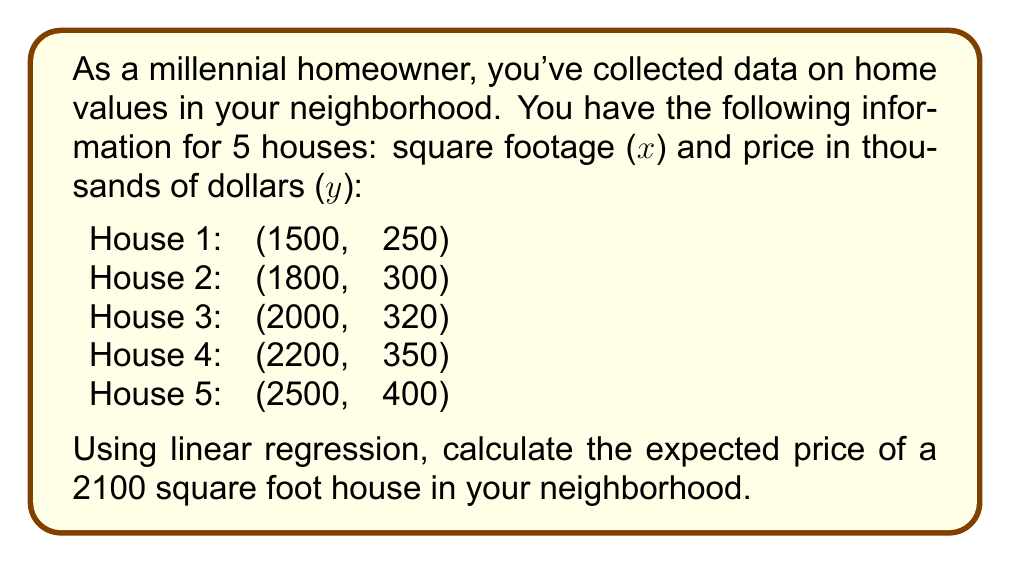Give your solution to this math problem. To solve this problem using linear regression, we'll follow these steps:

1. Calculate the means of x and y:
   $\bar{x} = \frac{1500 + 1800 + 2000 + 2200 + 2500}{5} = 2000$
   $\bar{y} = \frac{250 + 300 + 320 + 350 + 400}{5} = 324$

2. Calculate the slope (m) using the formula:
   $$m = \frac{\sum (x_i - \bar{x})(y_i - \bar{y})}{\sum (x_i - \bar{x})^2}$$

   Numerator: $(-500)(-74) + (-200)(-24) + 0(-4) + 200(26) + 500(76) = 82000$
   Denominator: $(-500)^2 + (-200)^2 + 0^2 + 200^2 + 500^2 = 580000$

   $m = \frac{82000}{580000} = 0.14138$

3. Calculate the y-intercept (b) using the formula:
   $$b = \bar{y} - m\bar{x}$$
   $b = 324 - 0.14138 * 2000 = 41.24$

4. The linear regression equation is:
   $$y = mx + b$$
   $$y = 0.14138x + 41.24$$

5. To find the expected price for a 2100 sq ft house, substitute x = 2100:
   $$y = 0.14138 * 2100 + 41.24 = 338.138$$
Answer: $338,138 